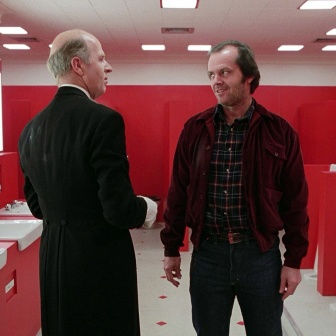This bathroom is in a magical realm. What unique properties does it have? In a magical realm, this bathroom could possess extraordinary properties. The mirrors could show glimpses of possible futures or alternate realities, allowing those who look into them to see crucial moments that could affect their destiny. The red tiles on the floor might change patterns to reveal hidden messages or maps when certain conditions are met. The sinks could produce enchanted water that heals or bestows temporary supernatural abilities upon those who drink it. The red walls might serve as portals to different locations within the magical realm, activated by specific spells or artifacts. This room, therefore, becomes a nexus of magic and intrigue, central to the unfolding of the realm's most significant events. Can you elaborate on a magical event that could take place in this red bathroom? One magical event that could take place in this red bathroom is the 'Convergence of Realities,' a rare occurrence where the boundaries between parallel universes temporarily dissolve. During this event, the mirrors would begin to ripple and show multiple versions of the sharegpt4v/same scene from alternate realities. The two men might be part of a secret society that safeguards the balance between these realities. As they converse, the red tiles might begin to glow, forming intricate paths and symbols that guide them to a hidden portal. This portal could lead them to a pivotal moment in another reality where they must act to prevent a catastrophe that would reverberate through all parallel worlds. The bathroom thus transforms into a critical juncture for their mission, filled with magical traps and enchantments they need to navigate while racing against time. 